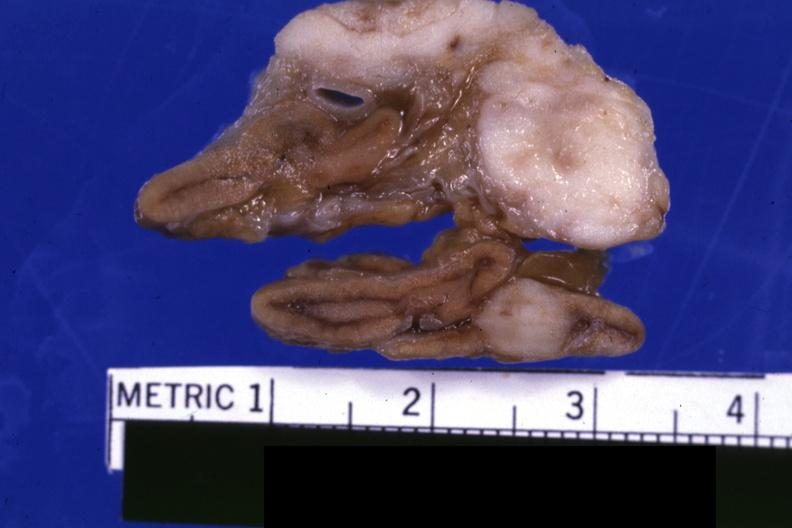s endocrine present?
Answer the question using a single word or phrase. Yes 